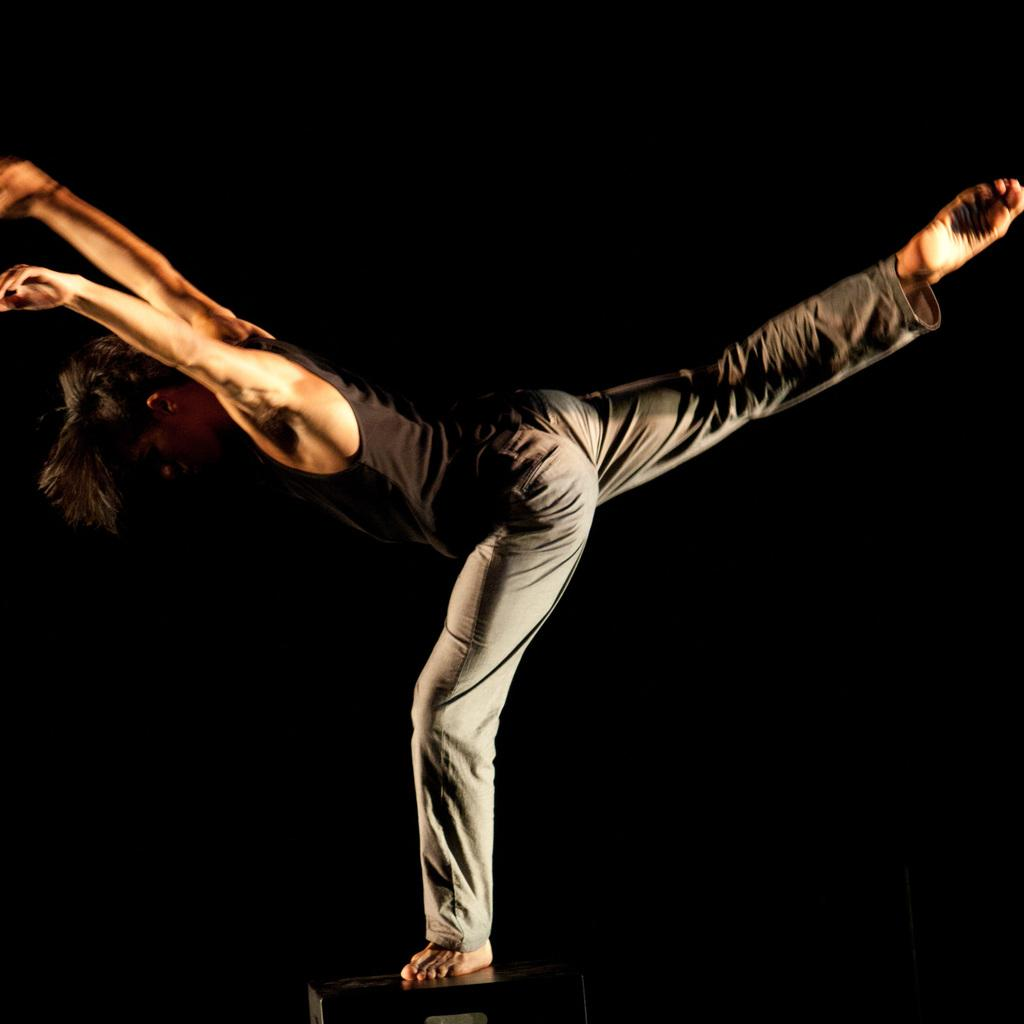What is the main subject of the image? There is a person in the image. What is the person doing in the image? The person is standing on a chair and has one leg raised. What type of toothpaste is the person using in the image? There is no toothpaste present in the image. What is the person mining for in the image? There is no mine or mining activity depicted in the image. 